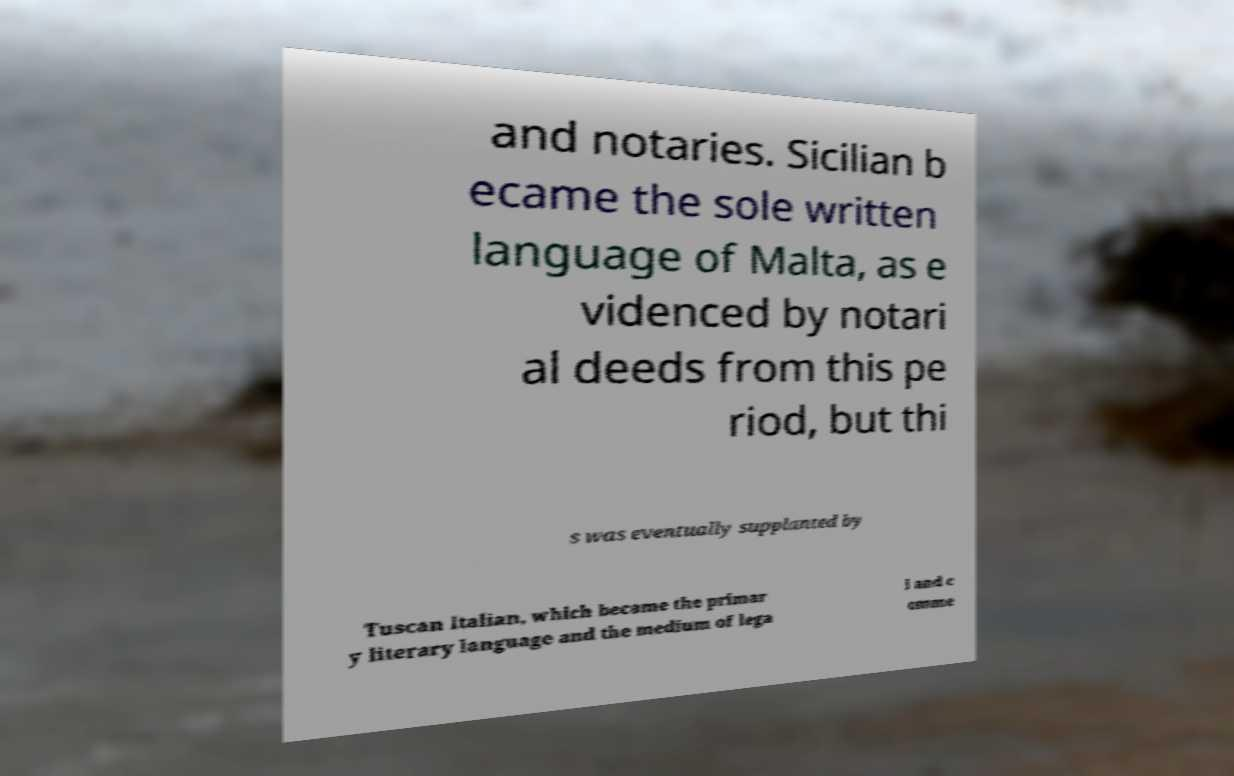I need the written content from this picture converted into text. Can you do that? and notaries. Sicilian b ecame the sole written language of Malta, as e videnced by notari al deeds from this pe riod, but thi s was eventually supplanted by Tuscan Italian, which became the primar y literary language and the medium of lega l and c omme 